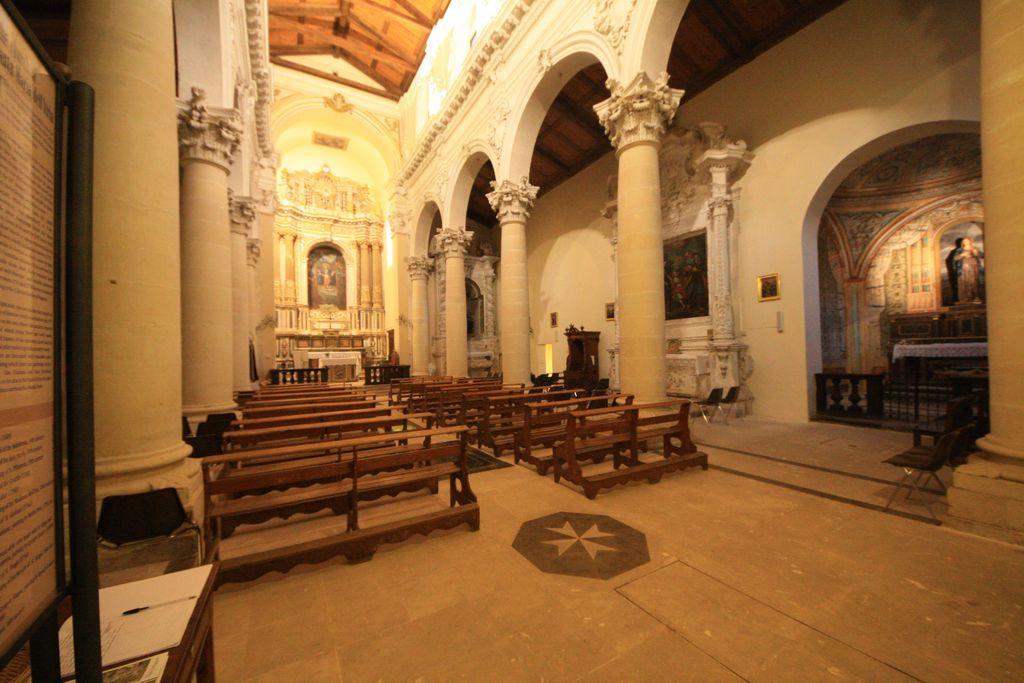Can you describe this image briefly? This image consists of a building. In the front, there are pillars. At the bottom, there are benches on the floor. On the left, we can see a board. On the right, there is an arch. At the top, there is a roof. 